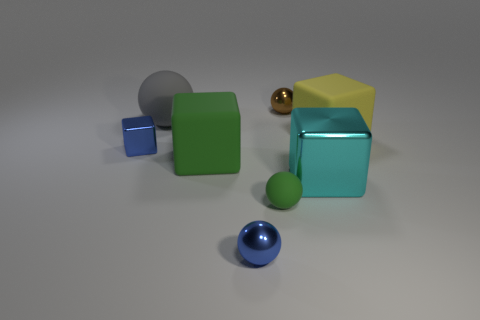Are there any other things of the same color as the tiny cube?
Offer a very short reply. Yes. What shape is the tiny brown object that is made of the same material as the small blue cube?
Ensure brevity in your answer.  Sphere. Is the big rubber ball the same color as the tiny matte object?
Offer a very short reply. No. Do the blue object on the right side of the gray rubber ball and the blue thing that is behind the big green block have the same material?
Your answer should be very brief. Yes. How many objects are gray rubber things or large things on the left side of the yellow block?
Provide a short and direct response. 3. Are there any other things that are the same material as the green sphere?
Offer a very short reply. Yes. There is a object that is the same color as the tiny rubber ball; what is its shape?
Provide a succinct answer. Cube. What material is the brown sphere?
Give a very brief answer. Metal. Is the big gray thing made of the same material as the green block?
Offer a terse response. Yes. What number of metal objects are blue cylinders or big spheres?
Provide a short and direct response. 0. 